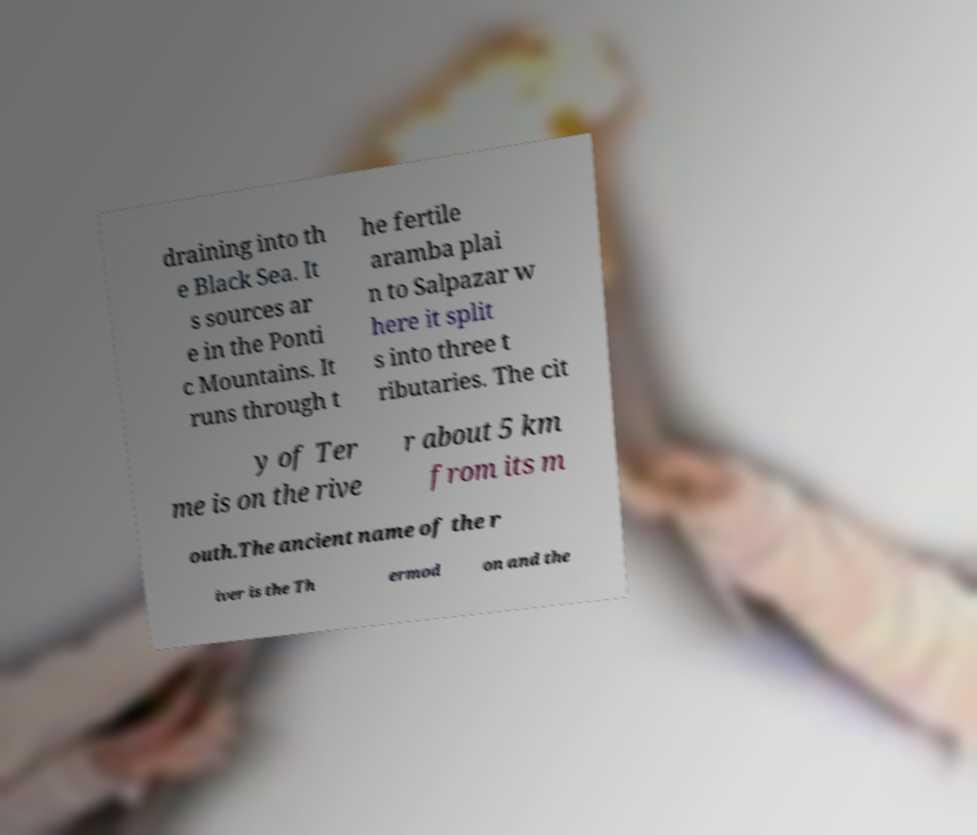Can you accurately transcribe the text from the provided image for me? draining into th e Black Sea. It s sources ar e in the Ponti c Mountains. It runs through t he fertile aramba plai n to Salpazar w here it split s into three t ributaries. The cit y of Ter me is on the rive r about 5 km from its m outh.The ancient name of the r iver is the Th ermod on and the 